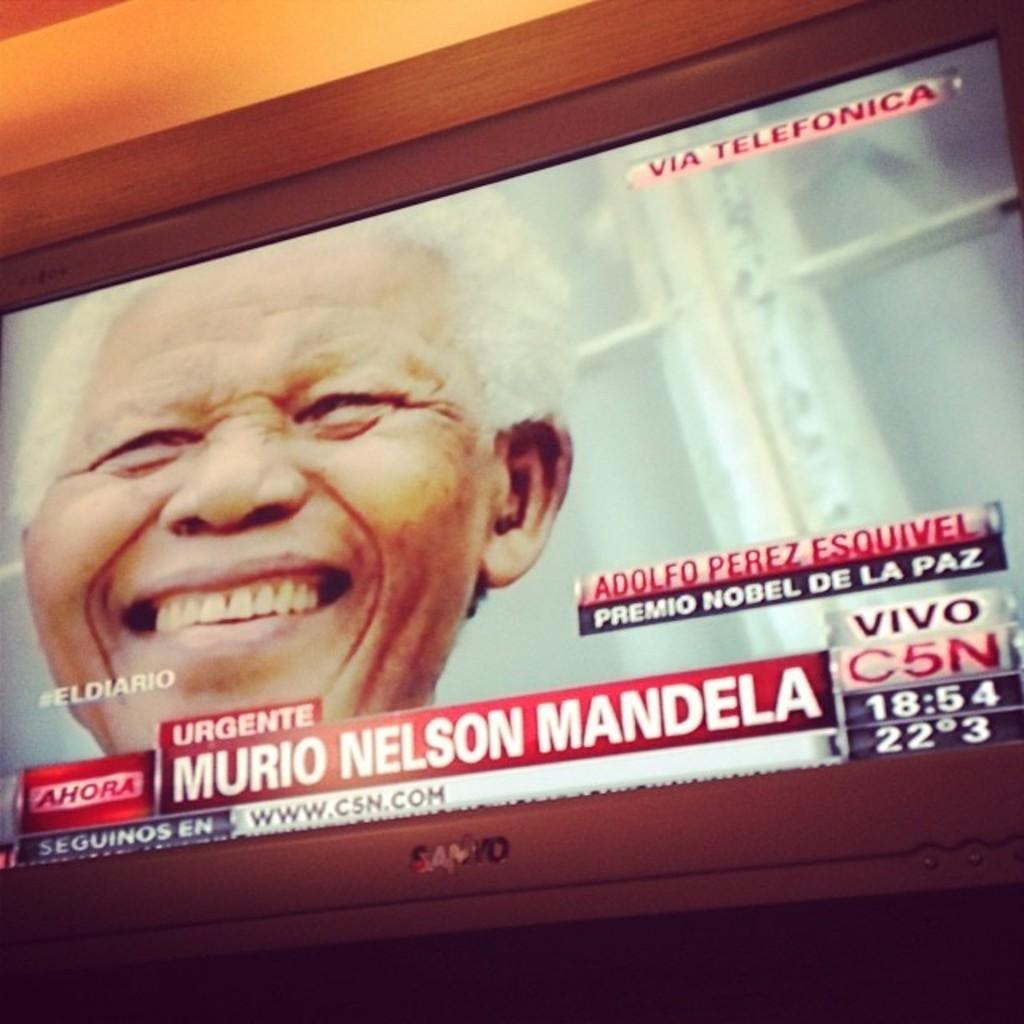Can you describe this image briefly? In the picture I can see a television in which I can see a person smiling and here we can see some edited text is displayed. 